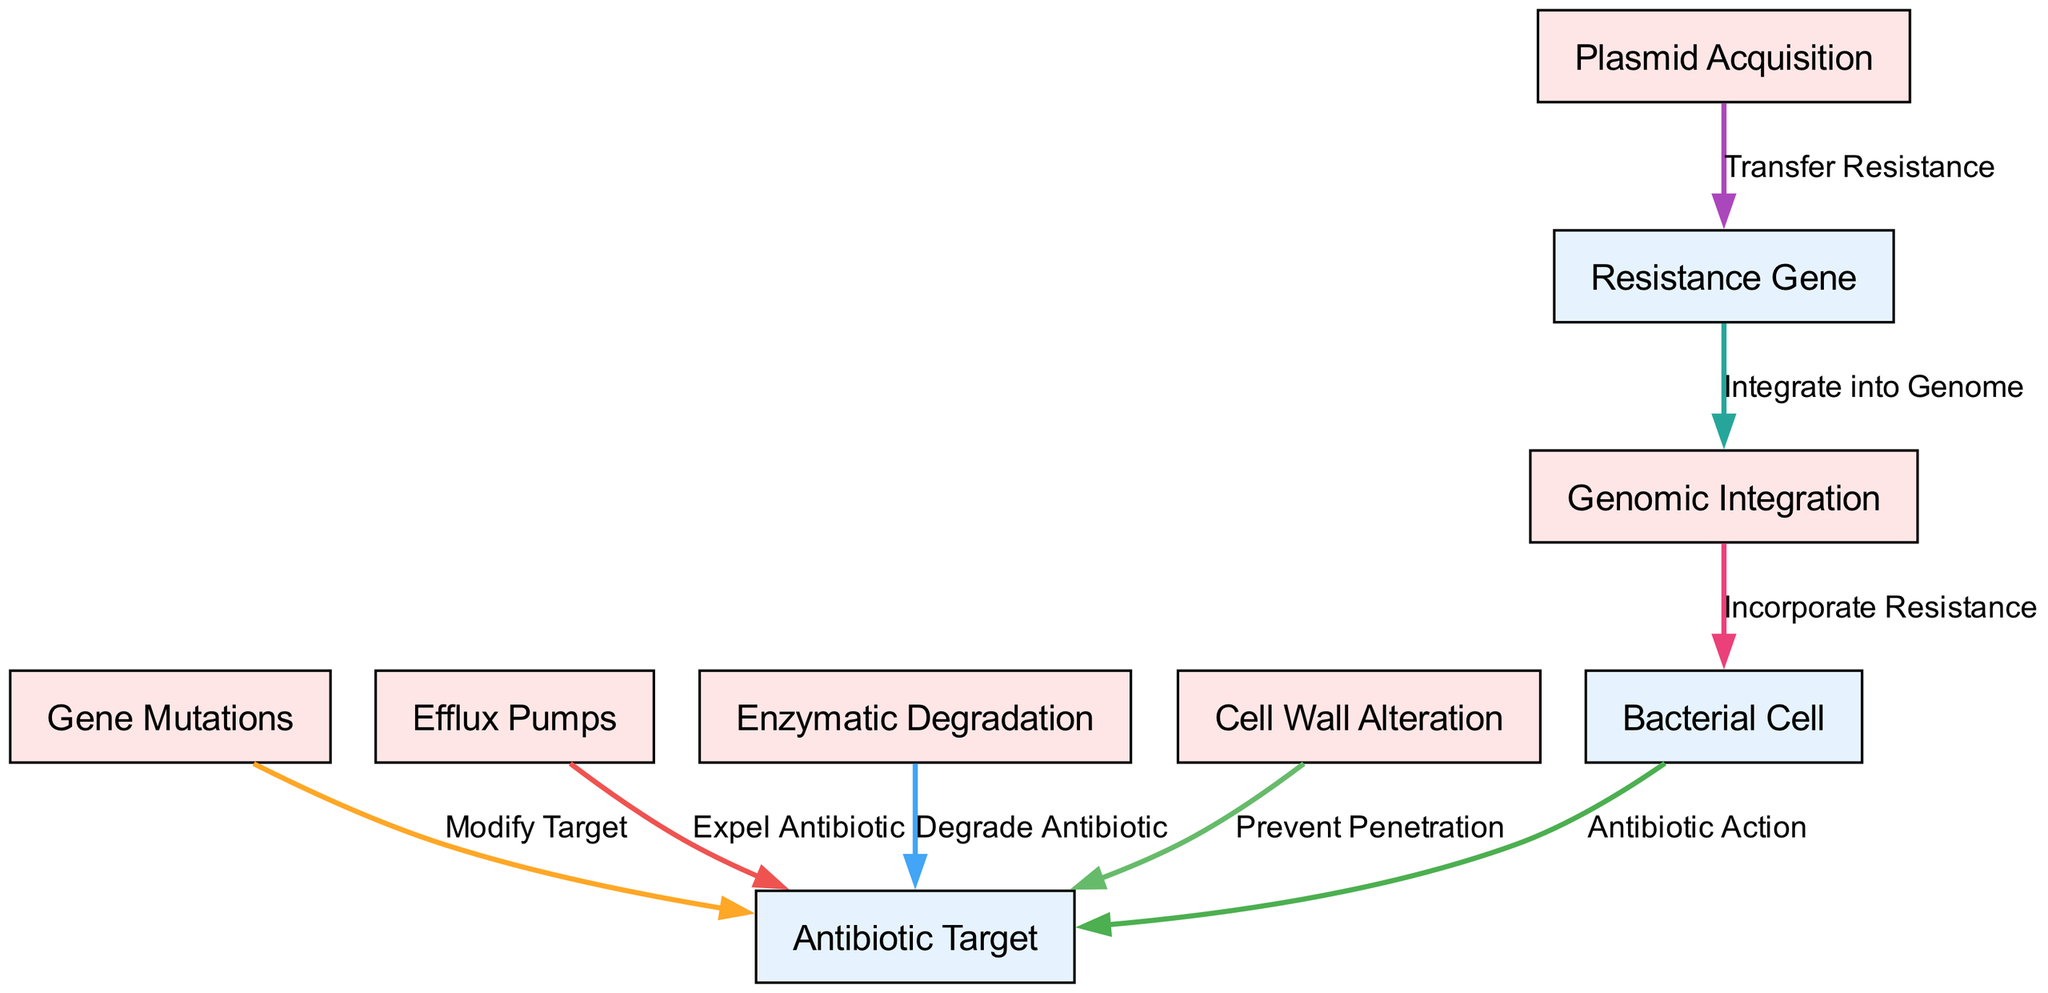What is the total number of nodes in the diagram? The diagram contains a list of nodes provided in the data. Counting the entities and mechanisms, there are 9 nodes listed: 6 entities and 3 mechanisms.
Answer: 9 What mechanism is used by bacteria to expel antibiotics? The diagram indicates that "Efflux Pumps" are the mechanism responsible for expelling antibiotics from the bacterial cell, as shown by the edge connecting them to the "Antibiotic Target."
Answer: Efflux Pumps What type of mechanism is "Gene Mutations"? In the context of the diagram, "Gene Mutations" is categorized as a "mechanism" since it describes a process that contributes to antibiotic resistance within the bacterial cell.
Answer: mechanism How many edges connect to the "Antibiotic Target"? Analyzing the relationships, the "Antibiotic Target" has 4 edges connecting it to various mechanisms, illustrating how resistance can occur through different methods.
Answer: 4 What influences "Antibiotic Target" by preventing penetration? The diagram shows "Cell Wall Alteration" linked with "Antibiotic Target," indicating that it prevents the antibiotic from entering the bacterial cell.
Answer: Cell Wall Alteration Which mechanism involves integrating a resistance gene into the genome? According to the diagram, "Genomic Integration" is the mechanism that allows the incorporation of a resistance gene into the bacterial genome, as evidenced by the connection from "Resistance Gene" to "Genomic Integration."
Answer: Genomic Integration What is the relationship between "Plasmid Acquisition" and "Resistance Gene"? The diagram outlines that "Plasmid Acquisition" transfers a resistance gene, indicating a direct flow of resistance between these two nodes.
Answer: Transfer Resistance What action do "Gene Mutations" take towards the "Antibiotic Target"? The diagram illustrates that "Gene Mutations" modify the antibiotic target, affecting its interaction with antibiotics and potentially leading to resistance.
Answer: Modify Target What is the ultimate effect of "Genomic Integration" on the "Bacterial Cell"? The diagram specifies that "Genomic Integration" leads to the incorporation of resistance within the bacterial cell, hence making it more resilient against antibiotics.
Answer: Incorporate Resistance 